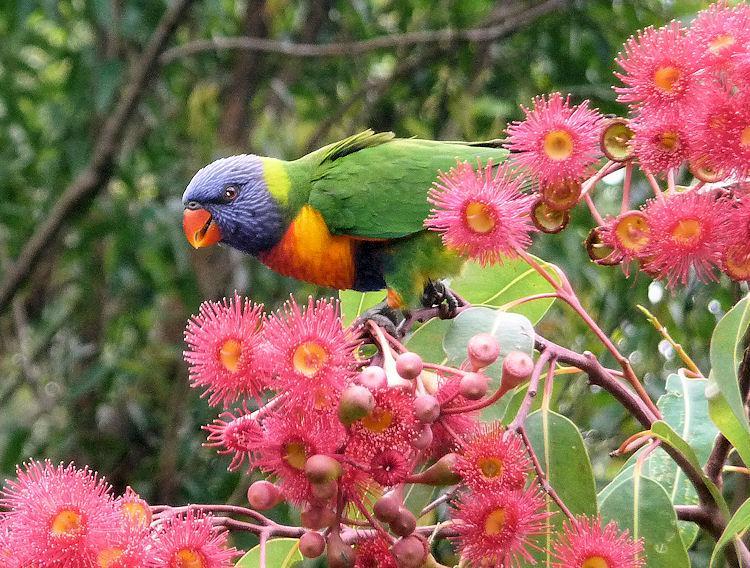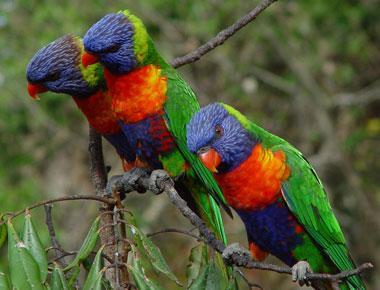The first image is the image on the left, the second image is the image on the right. Considering the images on both sides, is "There are at least four birds in total." valid? Answer yes or no. Yes. The first image is the image on the left, the second image is the image on the right. Evaluate the accuracy of this statement regarding the images: "In both image the rainbow lorikeet is eating.". Is it true? Answer yes or no. No. 